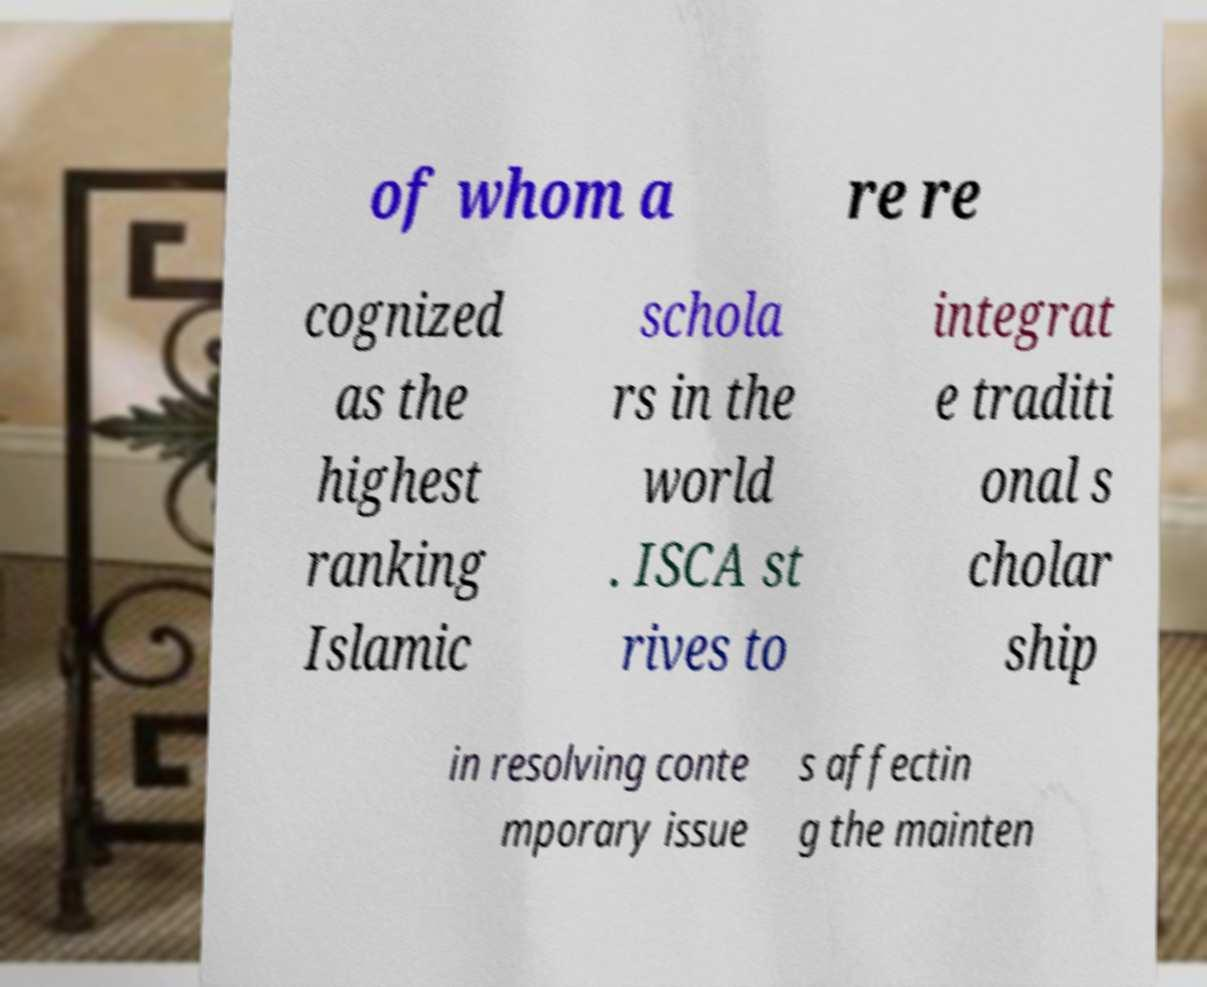For documentation purposes, I need the text within this image transcribed. Could you provide that? of whom a re re cognized as the highest ranking Islamic schola rs in the world . ISCA st rives to integrat e traditi onal s cholar ship in resolving conte mporary issue s affectin g the mainten 